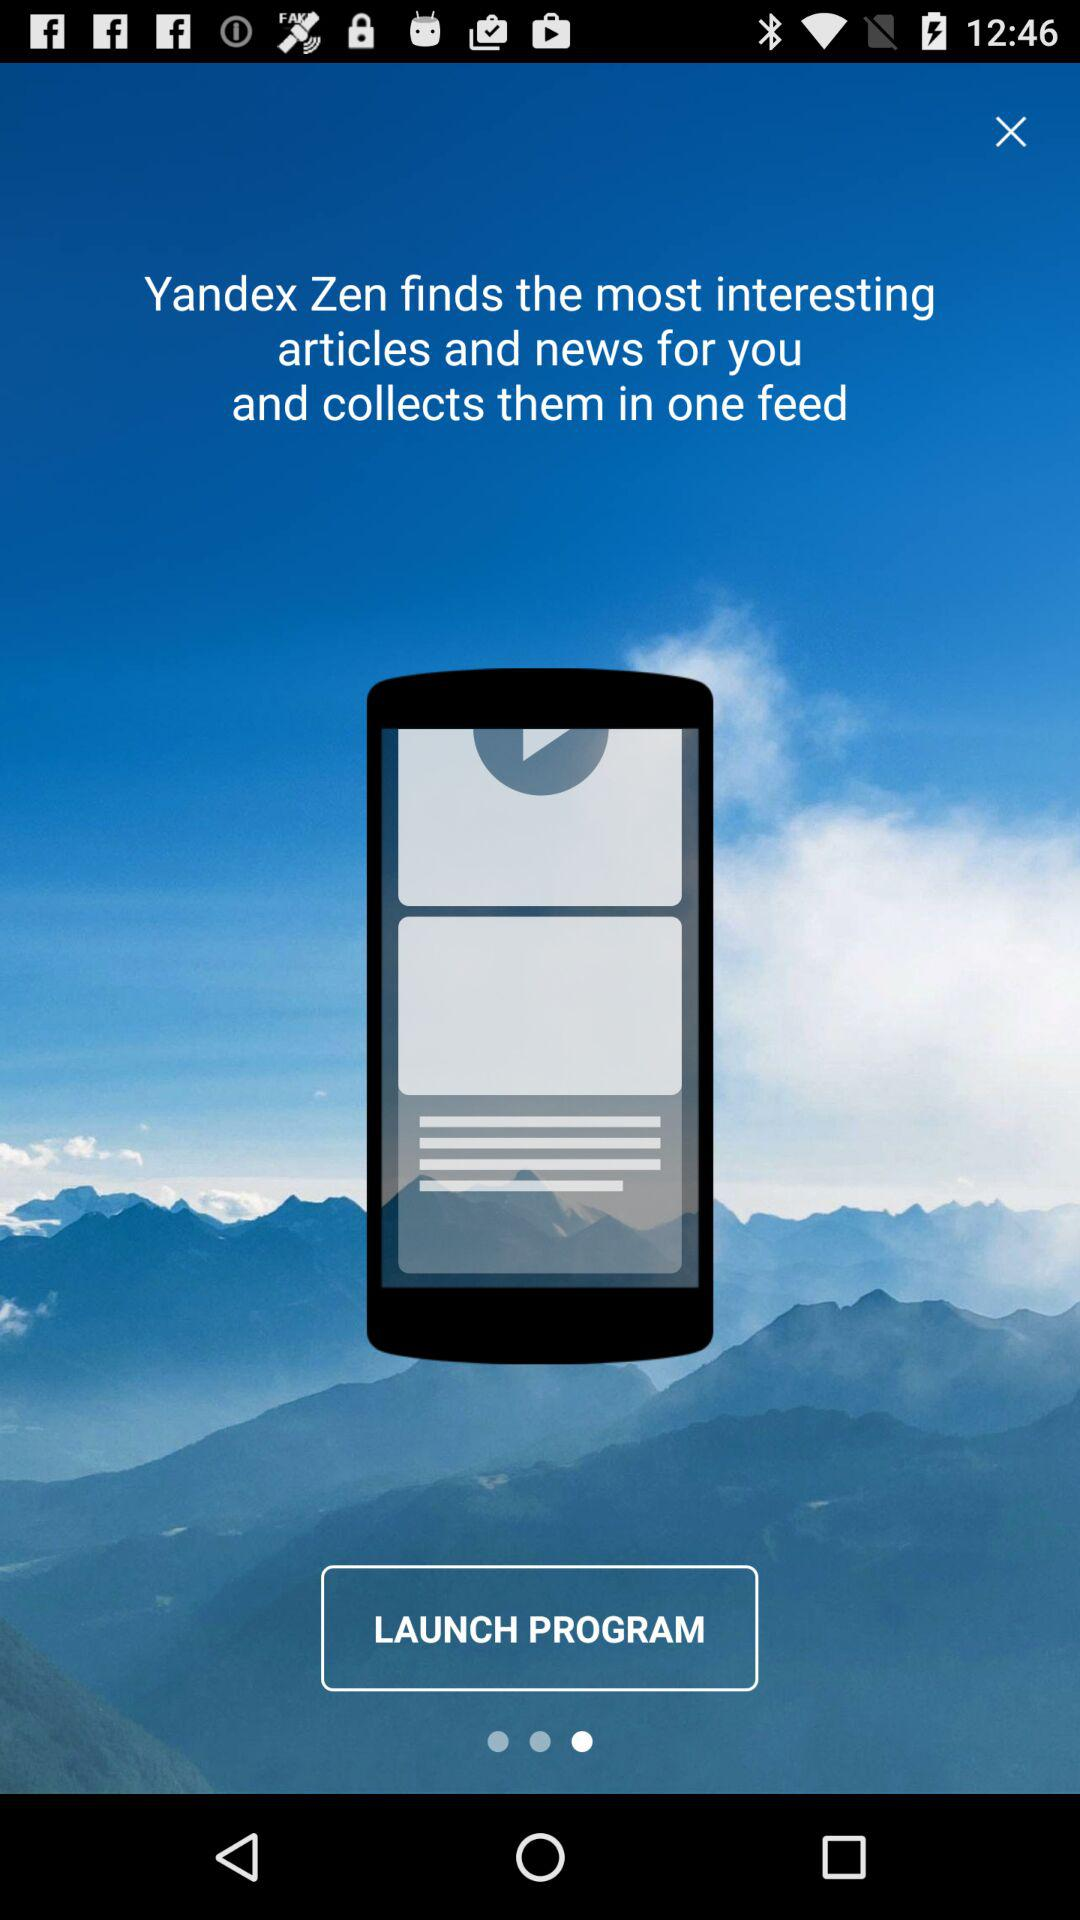What is the name of the application? The name of the application is "Yandex Zen". 